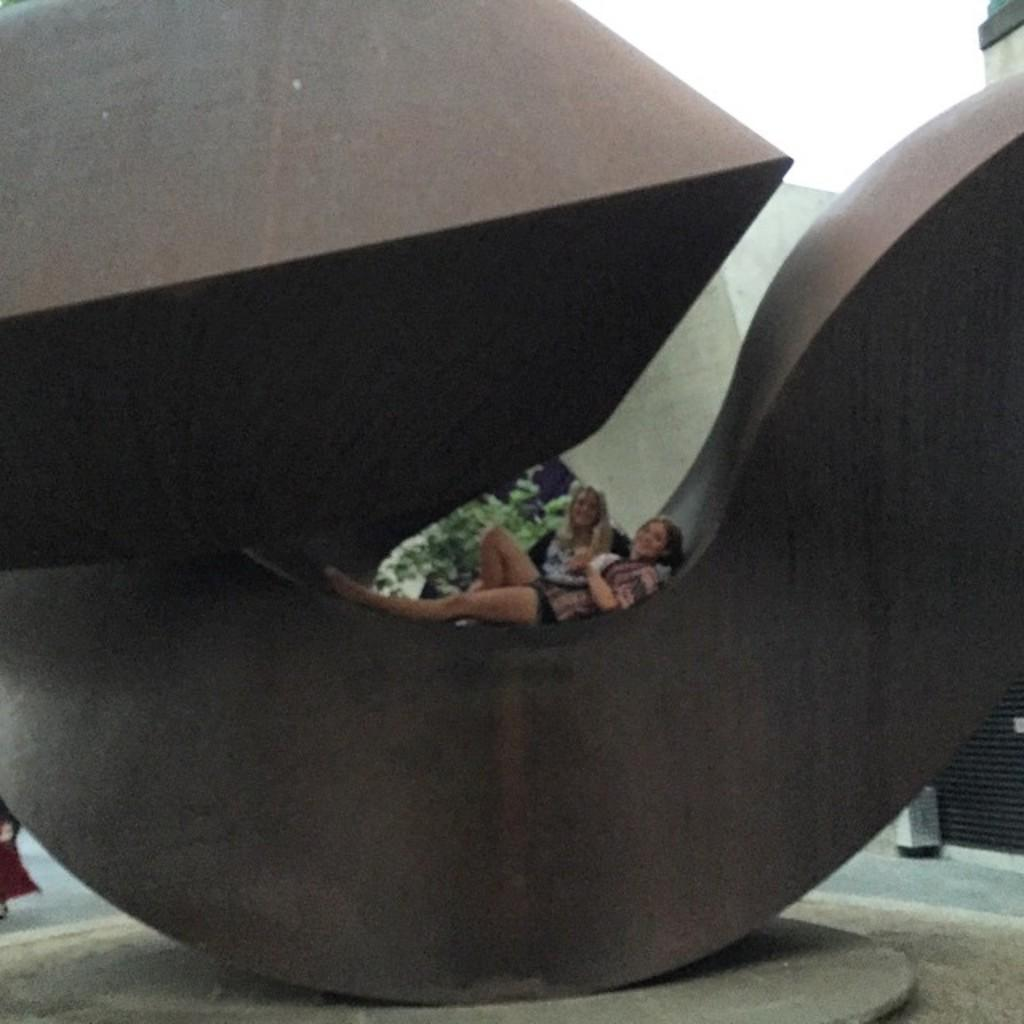How many people are in the image? There are two women in the image. What are the women doing in the image? The women are laying on a metal architecture. What expression do the women have in the image? The women have smiles on their faces. What type of needle is the woman holding in the image? There is no needle present in the image; the women are laying on a metal architecture and have smiles on their faces. 